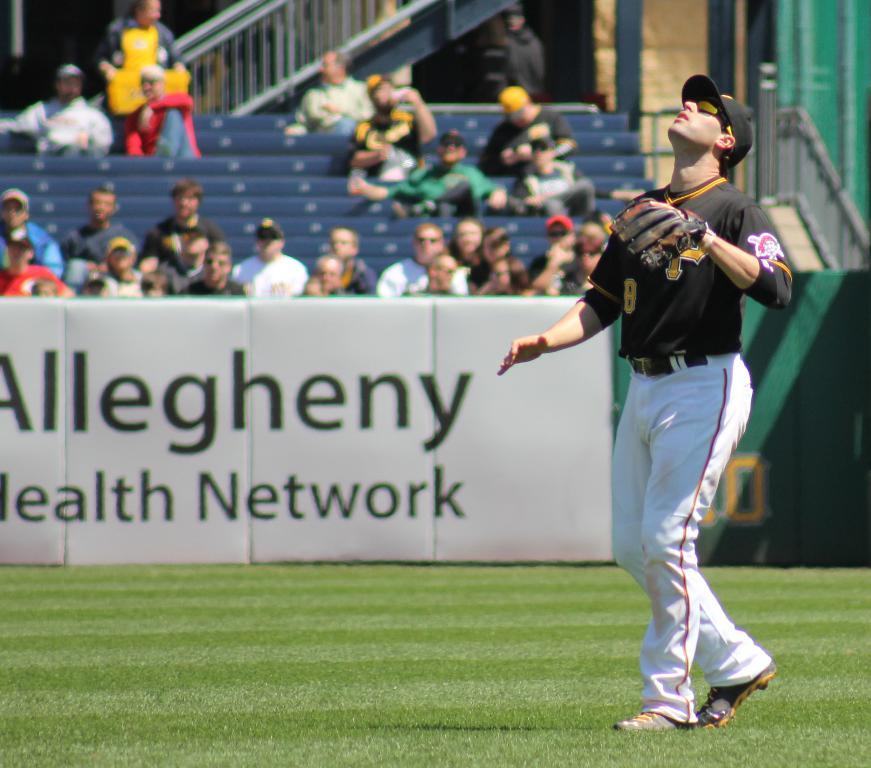Provide a one-sentence caption for the provided image. A pirates baseball player looking up at a ball he is about to try to catch. 